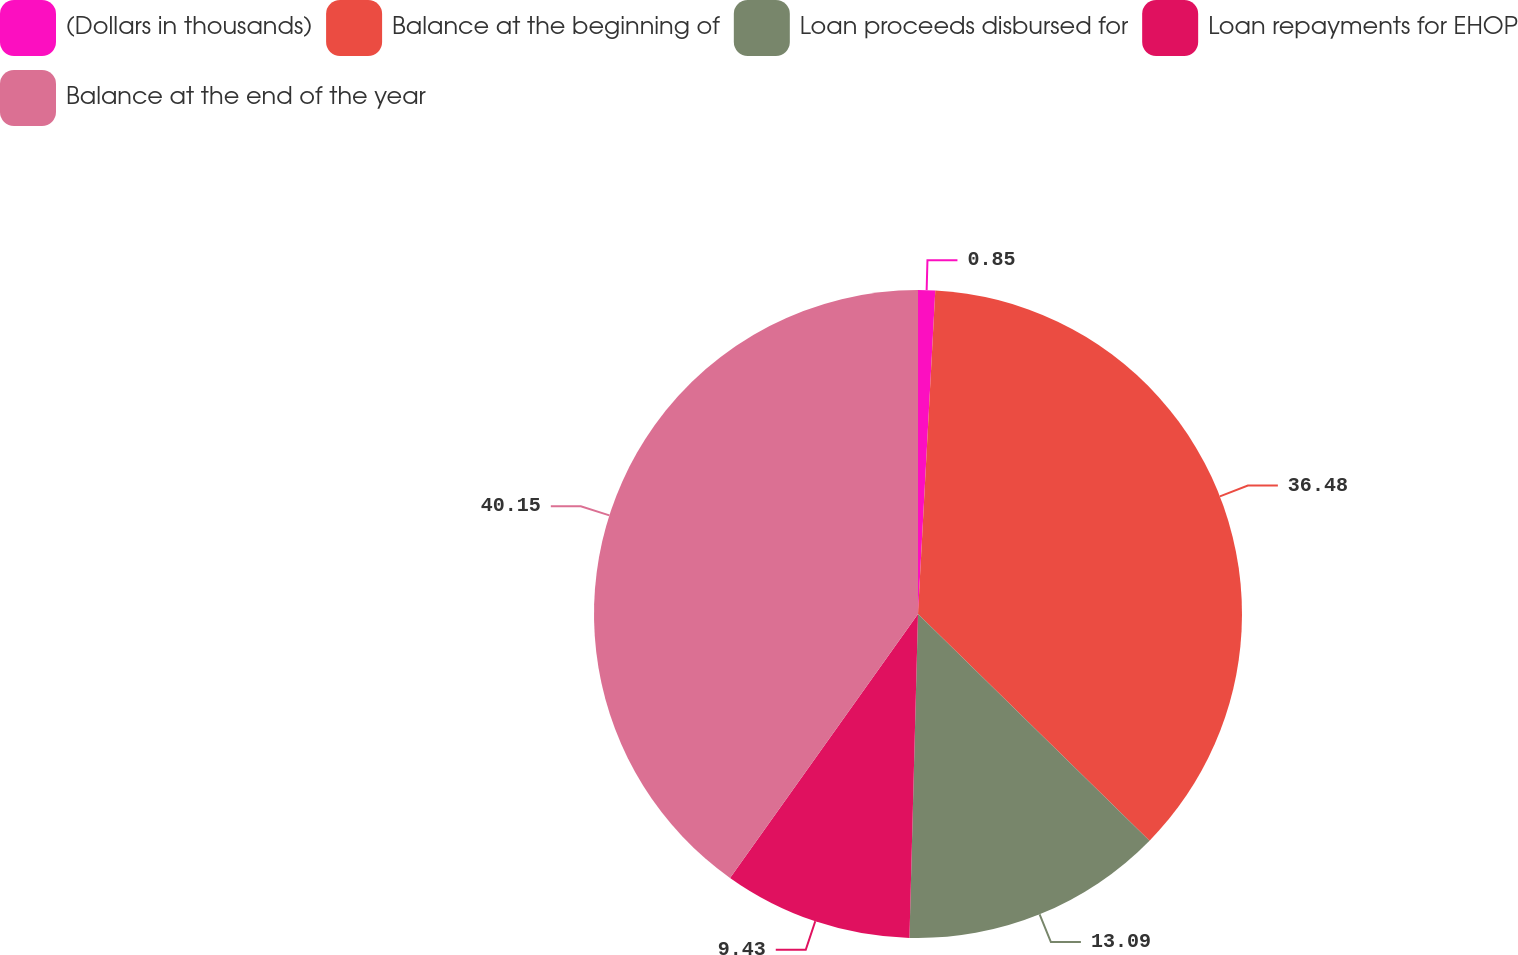Convert chart. <chart><loc_0><loc_0><loc_500><loc_500><pie_chart><fcel>(Dollars in thousands)<fcel>Balance at the beginning of<fcel>Loan proceeds disbursed for<fcel>Loan repayments for EHOP<fcel>Balance at the end of the year<nl><fcel>0.85%<fcel>36.48%<fcel>13.09%<fcel>9.43%<fcel>40.15%<nl></chart> 